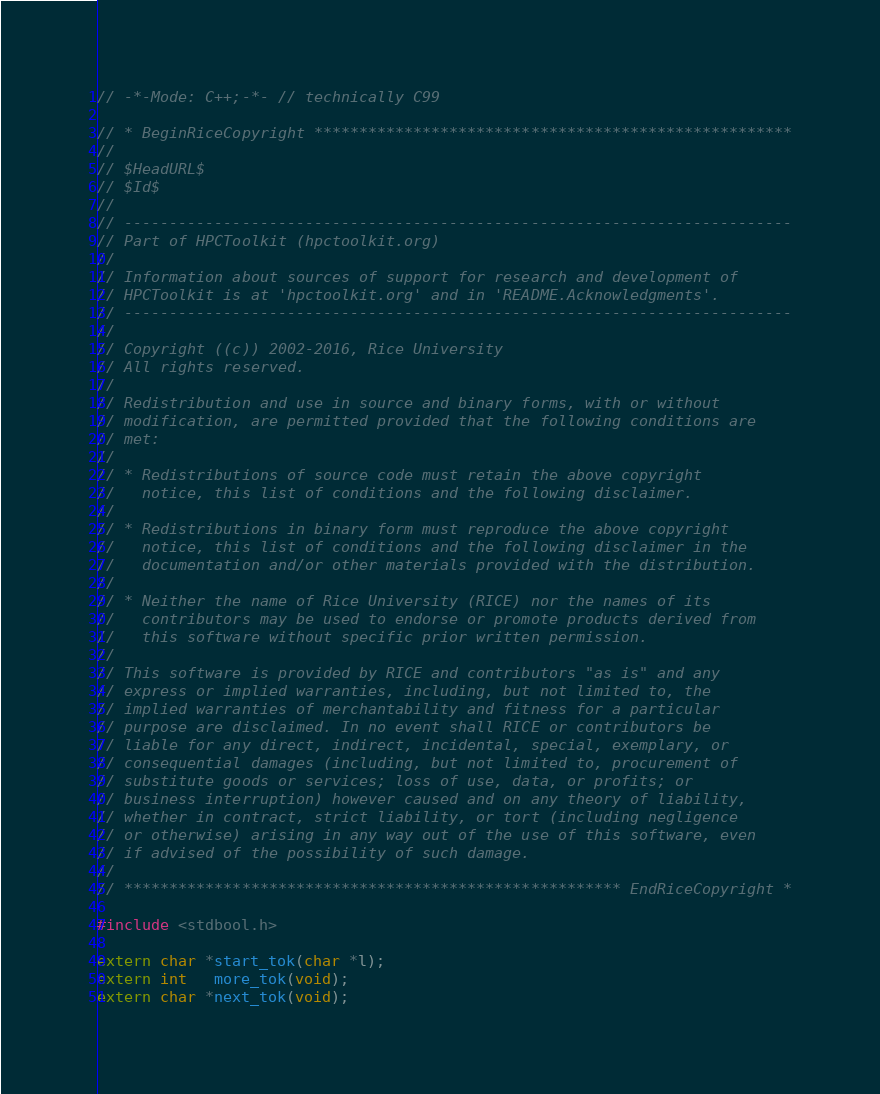Convert code to text. <code><loc_0><loc_0><loc_500><loc_500><_C_>// -*-Mode: C++;-*- // technically C99

// * BeginRiceCopyright *****************************************************
//
// $HeadURL$
// $Id$
//
// --------------------------------------------------------------------------
// Part of HPCToolkit (hpctoolkit.org)
//
// Information about sources of support for research and development of
// HPCToolkit is at 'hpctoolkit.org' and in 'README.Acknowledgments'.
// --------------------------------------------------------------------------
//
// Copyright ((c)) 2002-2016, Rice University
// All rights reserved.
//
// Redistribution and use in source and binary forms, with or without
// modification, are permitted provided that the following conditions are
// met:
//
// * Redistributions of source code must retain the above copyright
//   notice, this list of conditions and the following disclaimer.
//
// * Redistributions in binary form must reproduce the above copyright
//   notice, this list of conditions and the following disclaimer in the
//   documentation and/or other materials provided with the distribution.
//
// * Neither the name of Rice University (RICE) nor the names of its
//   contributors may be used to endorse or promote products derived from
//   this software without specific prior written permission.
//
// This software is provided by RICE and contributors "as is" and any
// express or implied warranties, including, but not limited to, the
// implied warranties of merchantability and fitness for a particular
// purpose are disclaimed. In no event shall RICE or contributors be
// liable for any direct, indirect, incidental, special, exemplary, or
// consequential damages (including, but not limited to, procurement of
// substitute goods or services; loss of use, data, or profits; or
// business interruption) however caused and on any theory of liability,
// whether in contract, strict liability, or tort (including negligence
// or otherwise) arising in any way out of the use of this software, even
// if advised of the possibility of such damage.
//
// ******************************************************* EndRiceCopyright *

#include <stdbool.h>

extern char *start_tok(char *l);
extern int   more_tok(void);
extern char *next_tok(void);</code> 